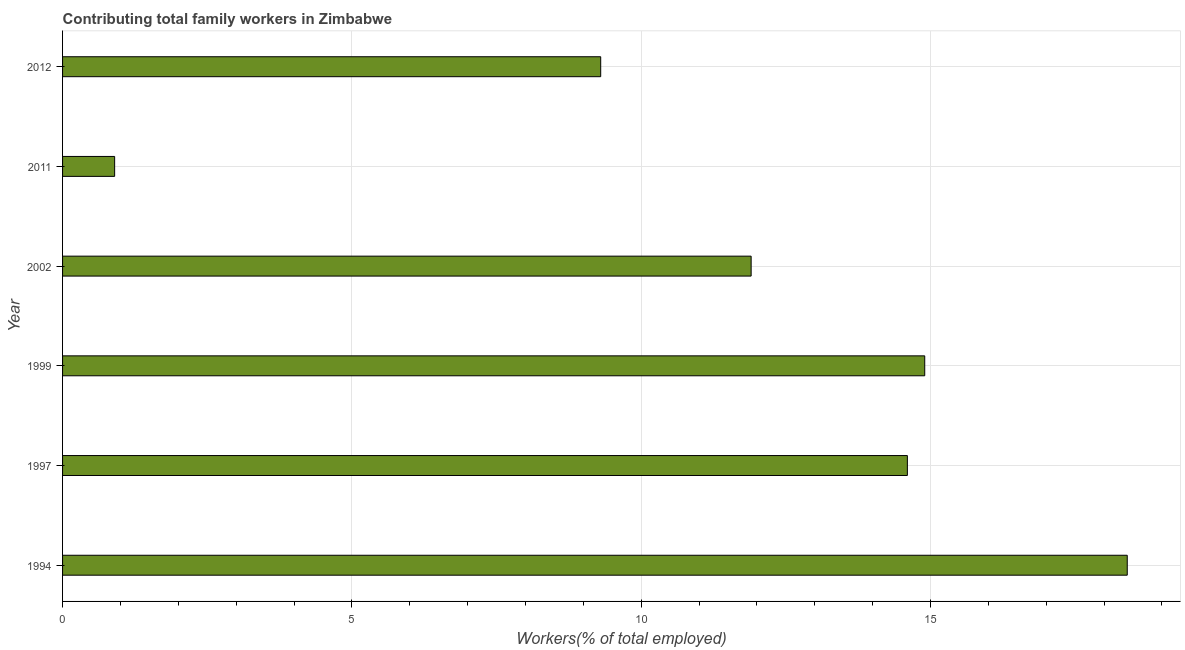Does the graph contain any zero values?
Give a very brief answer. No. Does the graph contain grids?
Make the answer very short. Yes. What is the title of the graph?
Your response must be concise. Contributing total family workers in Zimbabwe. What is the label or title of the X-axis?
Offer a terse response. Workers(% of total employed). What is the contributing family workers in 1994?
Provide a short and direct response. 18.4. Across all years, what is the maximum contributing family workers?
Make the answer very short. 18.4. Across all years, what is the minimum contributing family workers?
Give a very brief answer. 0.9. In which year was the contributing family workers maximum?
Make the answer very short. 1994. In which year was the contributing family workers minimum?
Give a very brief answer. 2011. What is the sum of the contributing family workers?
Offer a terse response. 70. What is the average contributing family workers per year?
Provide a succinct answer. 11.67. What is the median contributing family workers?
Your answer should be compact. 13.25. In how many years, is the contributing family workers greater than 1 %?
Your answer should be compact. 5. Do a majority of the years between 2002 and 2012 (inclusive) have contributing family workers greater than 8 %?
Offer a terse response. Yes. What is the ratio of the contributing family workers in 1994 to that in 1999?
Offer a terse response. 1.24. Is the contributing family workers in 1994 less than that in 2011?
Keep it short and to the point. No. Is the difference between the contributing family workers in 1999 and 2012 greater than the difference between any two years?
Make the answer very short. No. What is the difference between the highest and the second highest contributing family workers?
Offer a terse response. 3.5. Is the sum of the contributing family workers in 1999 and 2011 greater than the maximum contributing family workers across all years?
Your response must be concise. No. What is the difference between the highest and the lowest contributing family workers?
Offer a terse response. 17.5. How many bars are there?
Make the answer very short. 6. Are the values on the major ticks of X-axis written in scientific E-notation?
Ensure brevity in your answer.  No. What is the Workers(% of total employed) in 1994?
Ensure brevity in your answer.  18.4. What is the Workers(% of total employed) in 1997?
Provide a succinct answer. 14.6. What is the Workers(% of total employed) of 1999?
Keep it short and to the point. 14.9. What is the Workers(% of total employed) in 2002?
Make the answer very short. 11.9. What is the Workers(% of total employed) in 2011?
Make the answer very short. 0.9. What is the Workers(% of total employed) of 2012?
Provide a succinct answer. 9.3. What is the difference between the Workers(% of total employed) in 1994 and 1997?
Your answer should be very brief. 3.8. What is the difference between the Workers(% of total employed) in 1994 and 1999?
Offer a very short reply. 3.5. What is the difference between the Workers(% of total employed) in 1994 and 2012?
Make the answer very short. 9.1. What is the difference between the Workers(% of total employed) in 1997 and 2002?
Keep it short and to the point. 2.7. What is the difference between the Workers(% of total employed) in 1999 and 2011?
Make the answer very short. 14. What is the difference between the Workers(% of total employed) in 2002 and 2011?
Your answer should be compact. 11. What is the difference between the Workers(% of total employed) in 2002 and 2012?
Ensure brevity in your answer.  2.6. What is the difference between the Workers(% of total employed) in 2011 and 2012?
Give a very brief answer. -8.4. What is the ratio of the Workers(% of total employed) in 1994 to that in 1997?
Your answer should be very brief. 1.26. What is the ratio of the Workers(% of total employed) in 1994 to that in 1999?
Your response must be concise. 1.24. What is the ratio of the Workers(% of total employed) in 1994 to that in 2002?
Keep it short and to the point. 1.55. What is the ratio of the Workers(% of total employed) in 1994 to that in 2011?
Make the answer very short. 20.44. What is the ratio of the Workers(% of total employed) in 1994 to that in 2012?
Make the answer very short. 1.98. What is the ratio of the Workers(% of total employed) in 1997 to that in 1999?
Ensure brevity in your answer.  0.98. What is the ratio of the Workers(% of total employed) in 1997 to that in 2002?
Offer a very short reply. 1.23. What is the ratio of the Workers(% of total employed) in 1997 to that in 2011?
Provide a succinct answer. 16.22. What is the ratio of the Workers(% of total employed) in 1997 to that in 2012?
Your answer should be very brief. 1.57. What is the ratio of the Workers(% of total employed) in 1999 to that in 2002?
Ensure brevity in your answer.  1.25. What is the ratio of the Workers(% of total employed) in 1999 to that in 2011?
Your answer should be very brief. 16.56. What is the ratio of the Workers(% of total employed) in 1999 to that in 2012?
Offer a terse response. 1.6. What is the ratio of the Workers(% of total employed) in 2002 to that in 2011?
Make the answer very short. 13.22. What is the ratio of the Workers(% of total employed) in 2002 to that in 2012?
Your response must be concise. 1.28. What is the ratio of the Workers(% of total employed) in 2011 to that in 2012?
Provide a short and direct response. 0.1. 